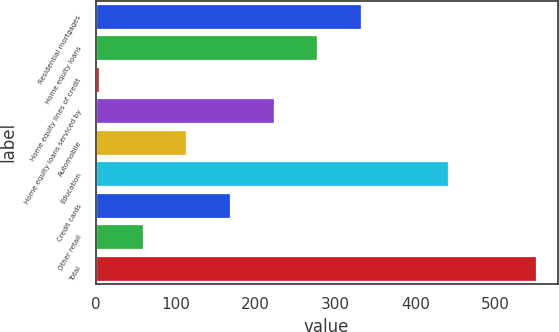Convert chart. <chart><loc_0><loc_0><loc_500><loc_500><bar_chart><fcel>Residential mortgages<fcel>Home equity loans<fcel>Home equity lines of credit<fcel>Home equity loans serviced by<fcel>Automobile<fcel>Education<fcel>Credit cards<fcel>Other retail<fcel>Total<nl><fcel>331.6<fcel>277<fcel>4<fcel>222.4<fcel>113.2<fcel>440.8<fcel>167.8<fcel>58.6<fcel>550<nl></chart> 